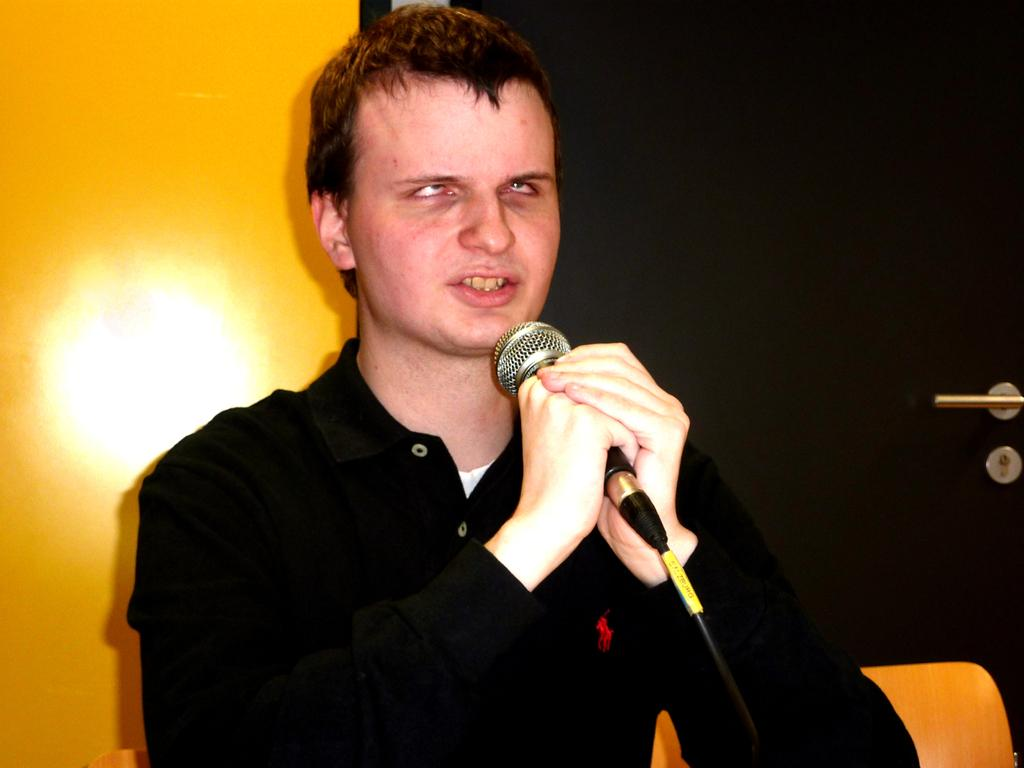What is the main subject of the image? The main subject of the image is a man. What is the man doing in the image? The man is standing and singing in the image. What object is the man holding? The man is holding a microphone in the image. What other objects can be seen in the image? There is a door and a chair in the image. What type of flower is on the windowsill in the image? There is no flower or windowsill present in the image; it features a man standing and singing while holding a microphone, with a door and a chair nearby. 